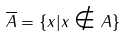Convert formula to latex. <formula><loc_0><loc_0><loc_500><loc_500>\overline { A } = \{ x | x \notin A \}</formula> 